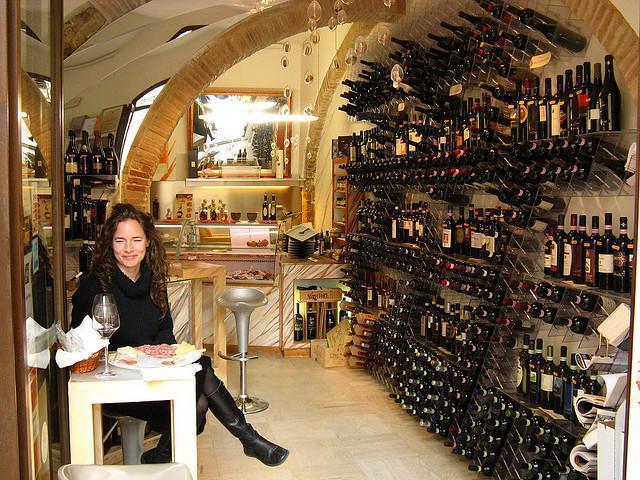How many dining tables are in the photo?
Give a very brief answer. 2. How many people can you see?
Give a very brief answer. 1. 